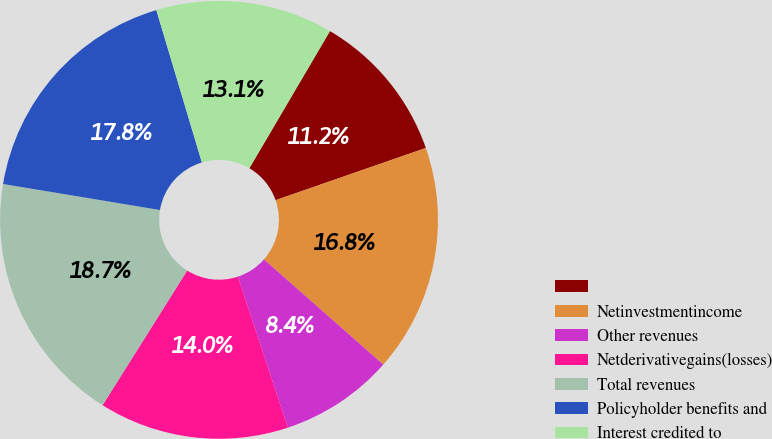Convert chart to OTSL. <chart><loc_0><loc_0><loc_500><loc_500><pie_chart><ecel><fcel>Netinvestmentincome<fcel>Other revenues<fcel>Netderivativegains(losses)<fcel>Total revenues<fcel>Policyholder benefits and<fcel>Interest credited to<nl><fcel>11.22%<fcel>16.82%<fcel>8.41%<fcel>14.02%<fcel>18.69%<fcel>17.76%<fcel>13.08%<nl></chart> 